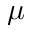<formula> <loc_0><loc_0><loc_500><loc_500>\mu</formula> 